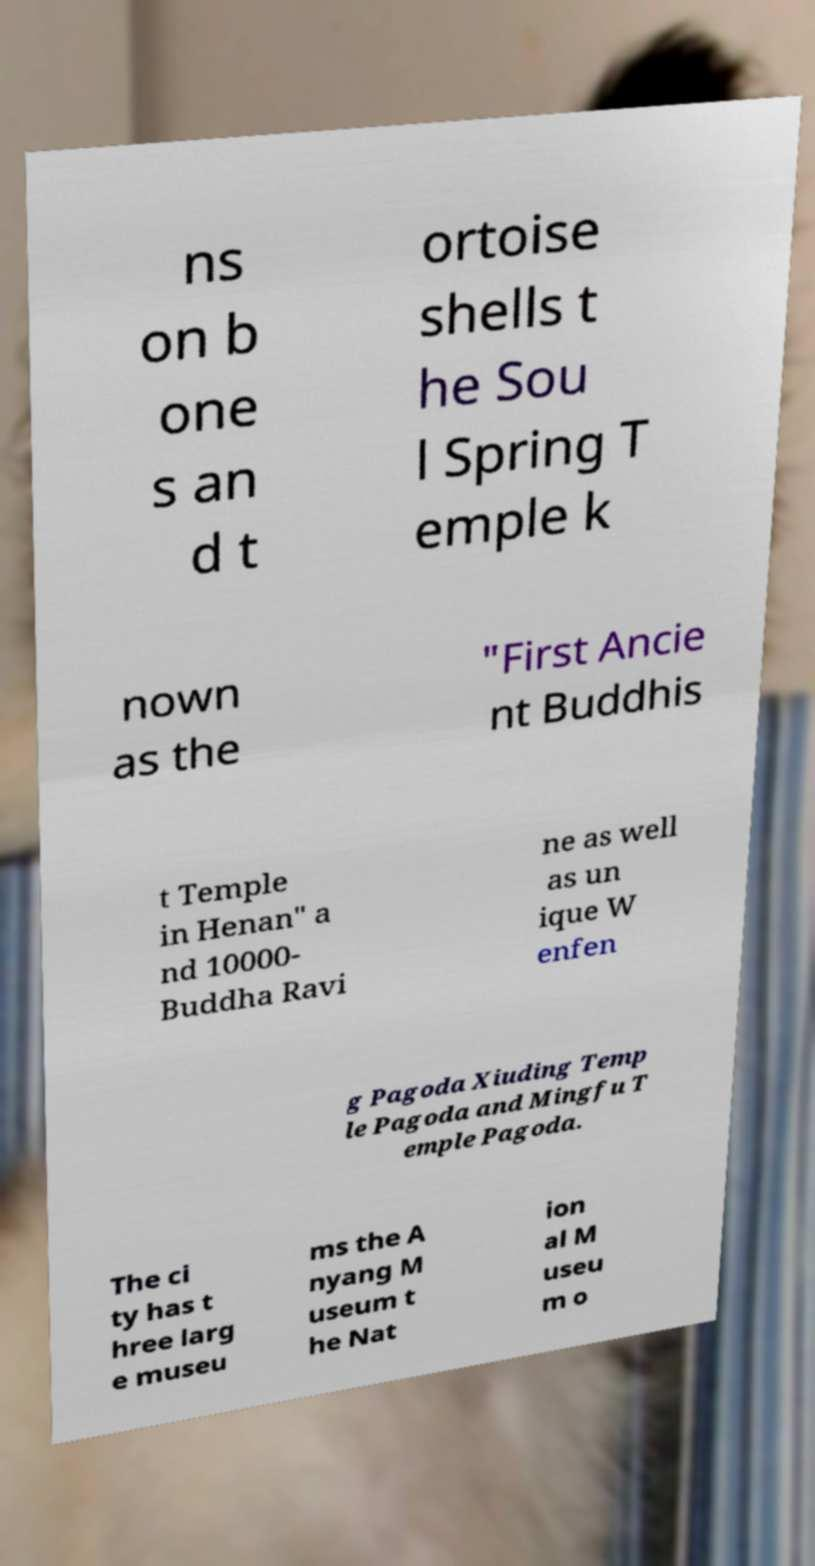I need the written content from this picture converted into text. Can you do that? ns on b one s an d t ortoise shells t he Sou l Spring T emple k nown as the "First Ancie nt Buddhis t Temple in Henan" a nd 10000- Buddha Ravi ne as well as un ique W enfen g Pagoda Xiuding Temp le Pagoda and Mingfu T emple Pagoda. The ci ty has t hree larg e museu ms the A nyang M useum t he Nat ion al M useu m o 